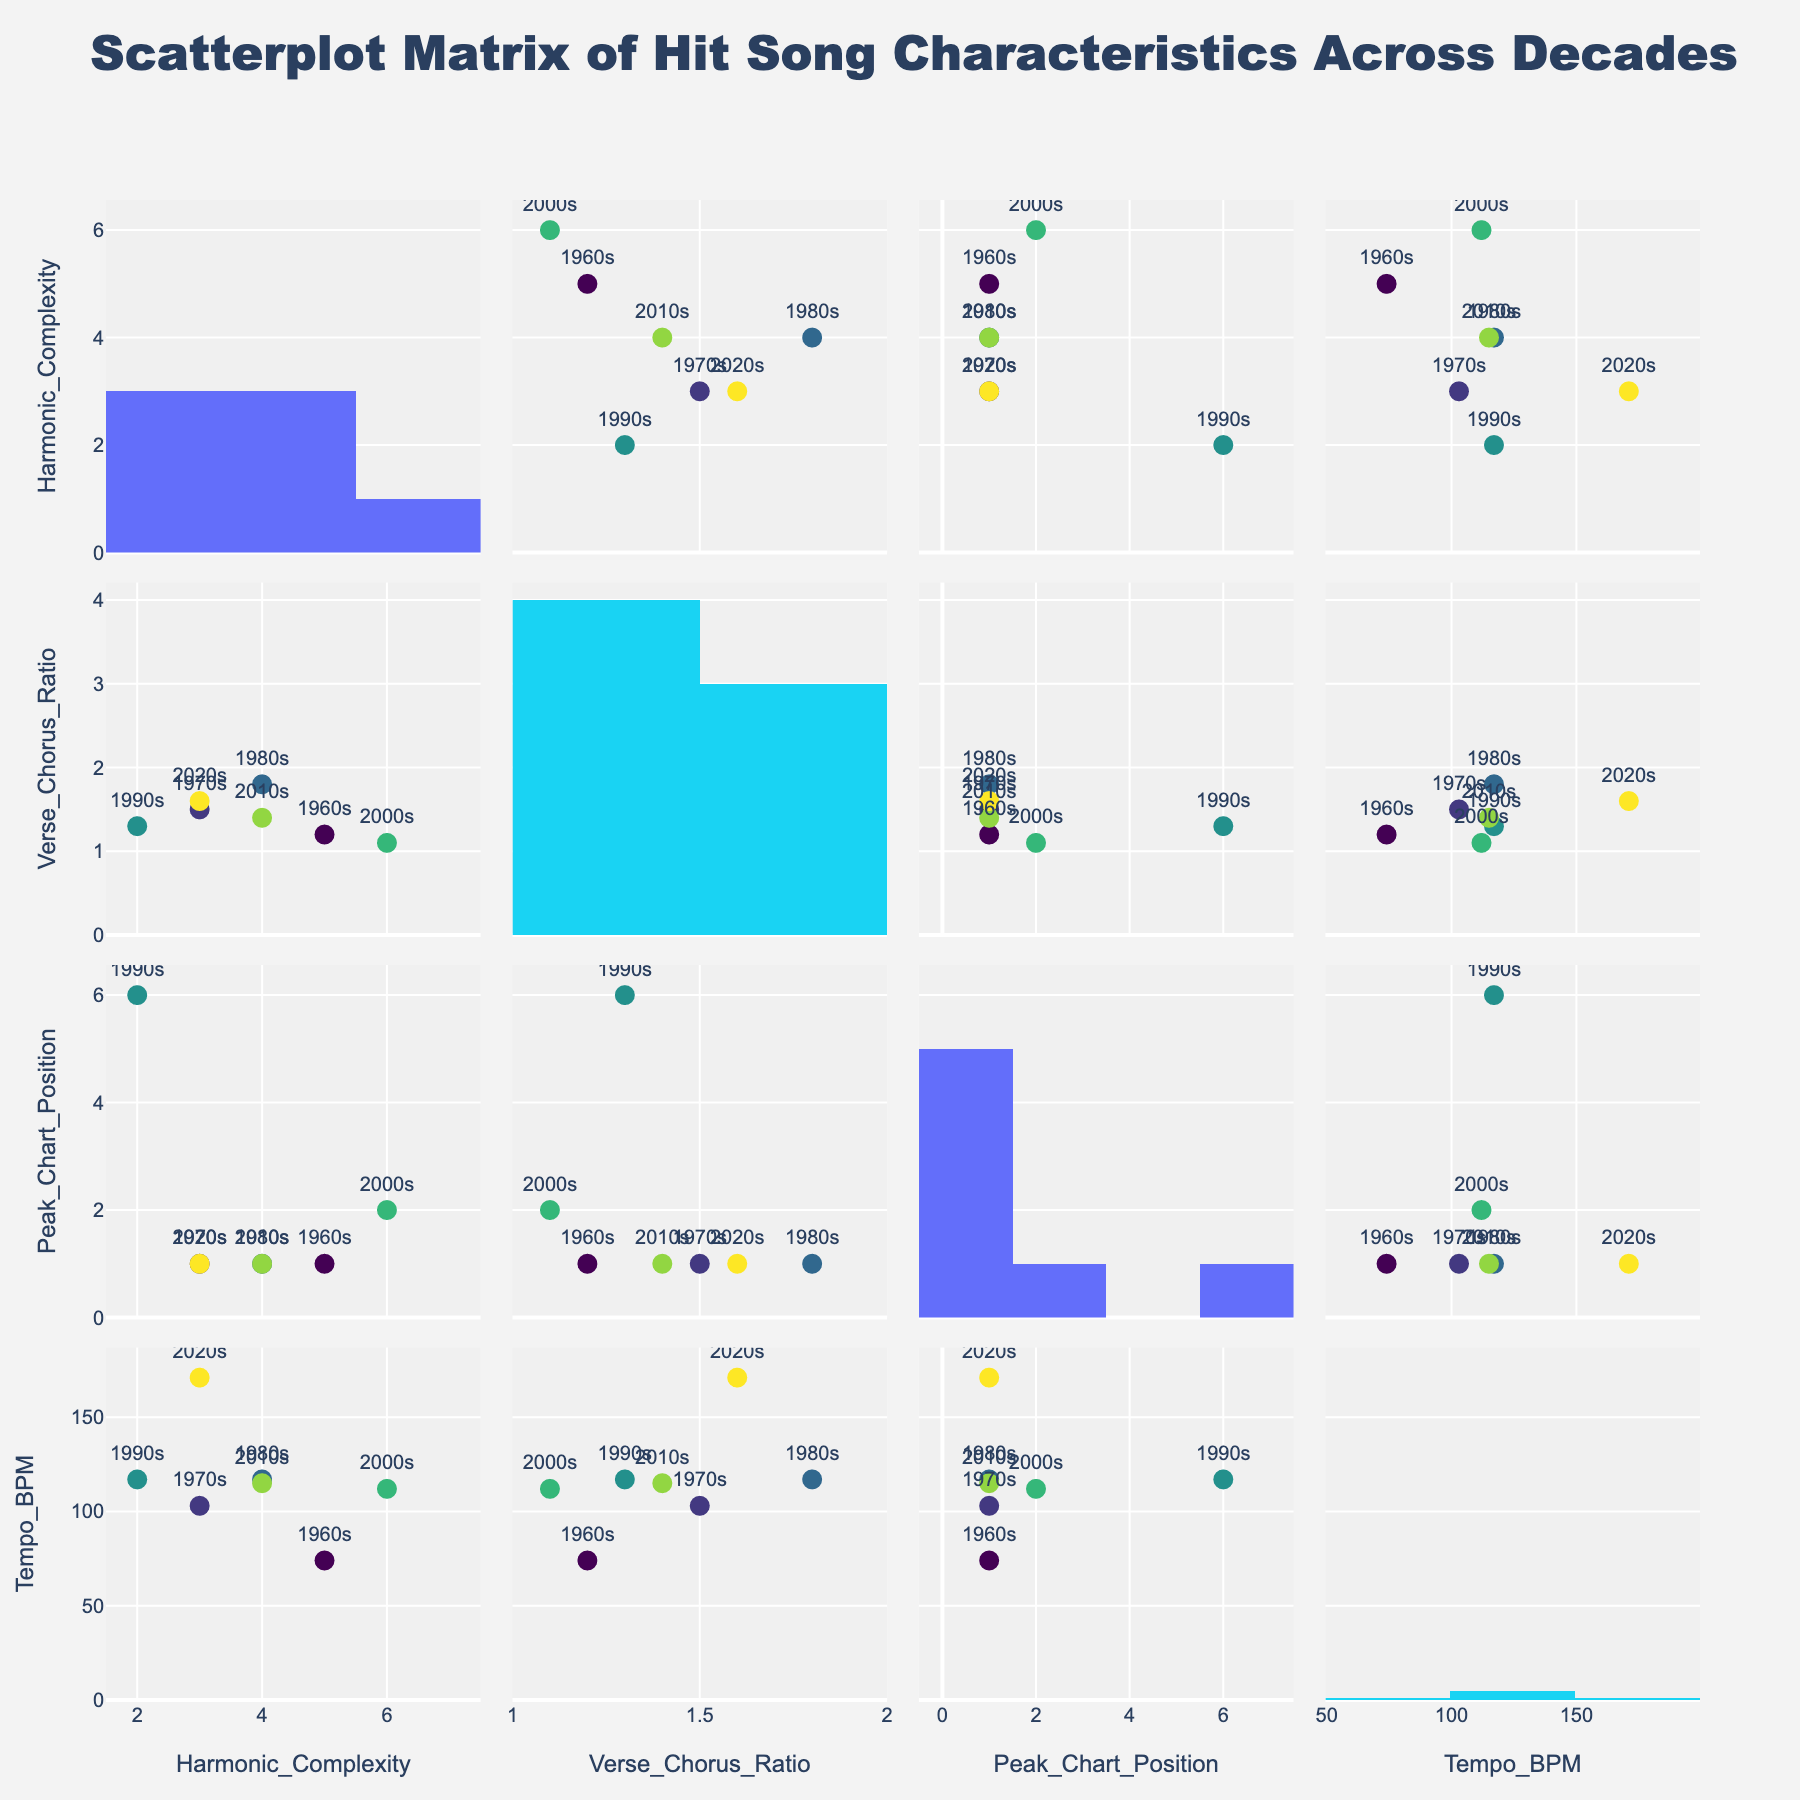How many hit songs from the 1960s are represented in the scatterplot matrix? Look at the scatterplot matrix and identify the number of data points labeled as '1960s'.
Answer: 1 Which decade shows the highest Tempo (BPM) in the scatterplot matrix? Find the data point with the highest Tempo (BPM) and check the decade label associated with that point.
Answer: 2020s In which decade is the Harmonic Complexity the highest? Find the highest value on the Harmonic Complexity axis and check the decade label associated with that point.
Answer: 2000s What is the average Tempo (BPM) for the songs from the 2010s and 2020s? Identify the Tempo (BPM) values for the songs from these decades, add them, and divide by the number of songs. (115 + 171) / 2 = 143
Answer: 143 Which song from the 1980s has a Verse Chorus Ratio greater than 1.5? Locate the data points on the Verse Chorus Ratio axis for the 1980s and identify which ones are greater than 1.5.
Answer: Billie Jean Compare the Harmonic Complexity of 'Hey Jude' and 'Blinding Lights'. Which song has a higher complexity? Find the respective points for 'Hey Jude' and 'Blinding Lights' on the Harmonic Complexity axis and see which is higher.
Answer: Hey Jude Is there any correlation visible between Peak Chart Position and Tempo (BPM)? Analyze the scatterplot for Peak Chart Position vs. Tempo (BPM) to see if there is a discernible trend or pattern.
Answer: No clear correlation How many songs have both Harmonic Complexity below 4 and Peak Chart Position equal to 1? Count the data points in the scatterplot matrix that meet both criteria.
Answer: 2 What decade has the maximum data points in the top-left quadrant of the Harmonic Complexity vs. Verse Chorus Ratio plot? Identify the number of data points from each decade in the specified quadrant.
Answer: 1970s 